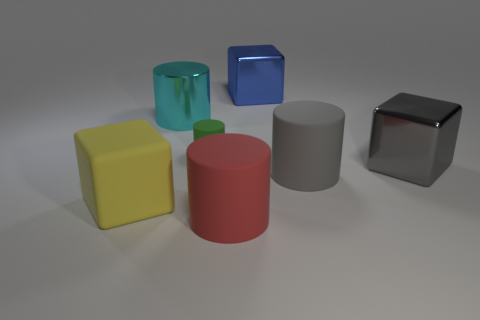Subtract all red cylinders. How many cylinders are left? 3 Add 2 yellow cubes. How many objects exist? 9 Subtract all blue cylinders. Subtract all yellow blocks. How many cylinders are left? 4 Subtract all cylinders. How many objects are left? 3 Subtract all yellow matte cubes. Subtract all brown matte cylinders. How many objects are left? 6 Add 6 gray cylinders. How many gray cylinders are left? 7 Add 4 gray objects. How many gray objects exist? 6 Subtract 0 yellow balls. How many objects are left? 7 